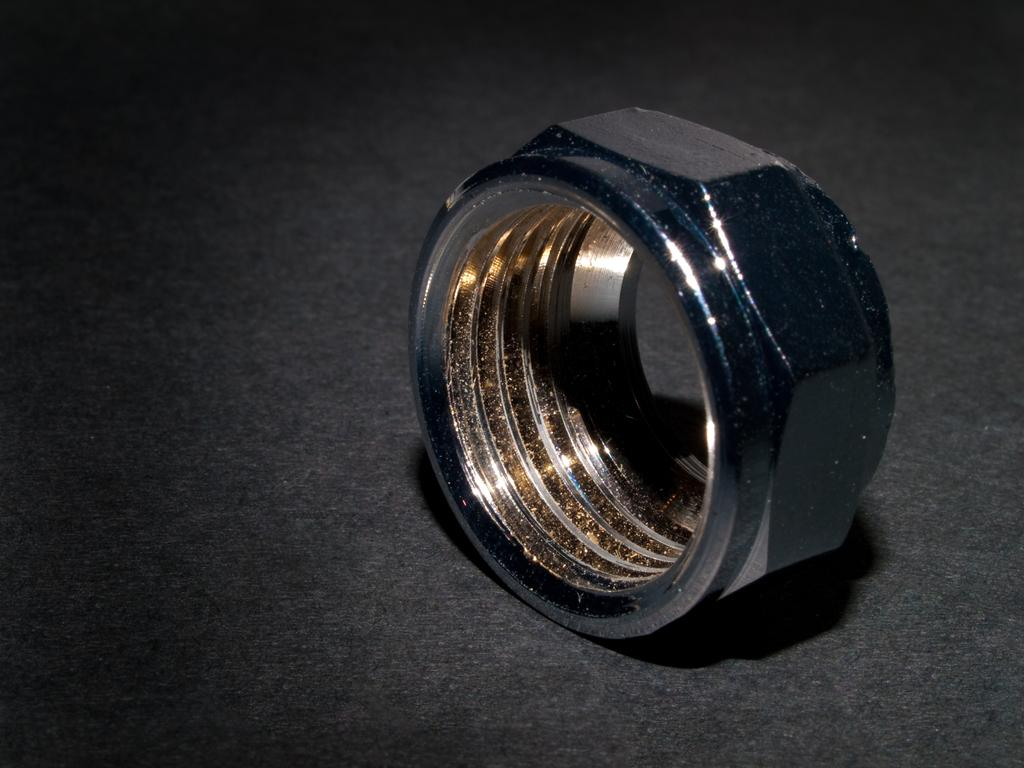What is present on the surface in the image? There is a bolt on the surface in the image. What type of fuel is required to operate the bolt in the image? The bolt in the image does not require any fuel to operate, as it is a stationary object. What achievements can be attributed to the bolt in the image? The bolt in the image is an inanimate object and does not have any achievements. 